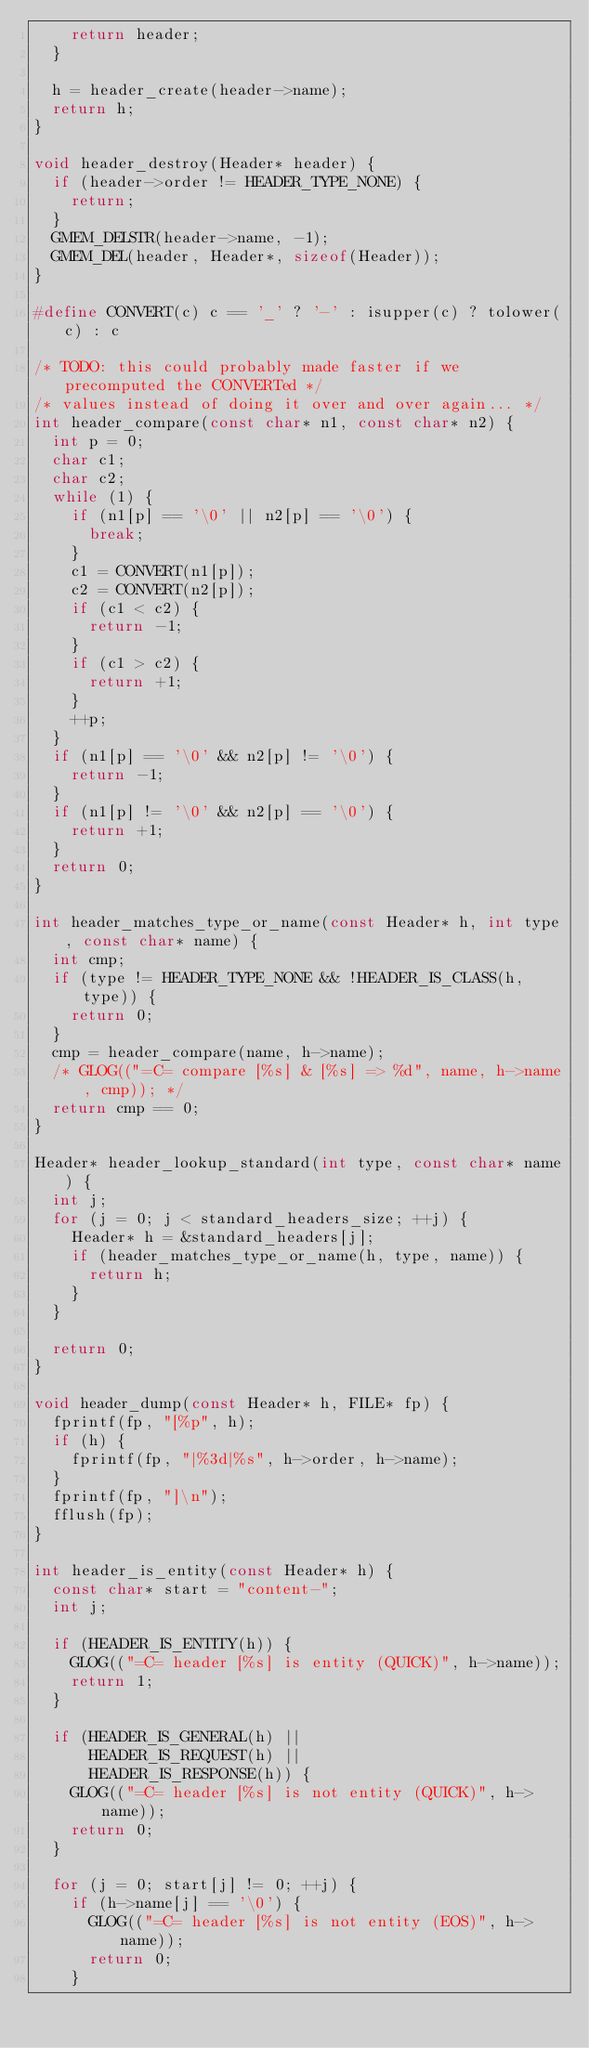<code> <loc_0><loc_0><loc_500><loc_500><_C_>    return header;
  }

  h = header_create(header->name);
  return h;
}

void header_destroy(Header* header) {
  if (header->order != HEADER_TYPE_NONE) {
    return;
  }
  GMEM_DELSTR(header->name, -1);
  GMEM_DEL(header, Header*, sizeof(Header));
}

#define CONVERT(c) c == '_' ? '-' : isupper(c) ? tolower(c) : c

/* TODO: this could probably made faster if we precomputed the CONVERTed */
/* values instead of doing it over and over again... */
int header_compare(const char* n1, const char* n2) {
  int p = 0;
  char c1;
  char c2;
  while (1) {
    if (n1[p] == '\0' || n2[p] == '\0') {
      break;
    }
    c1 = CONVERT(n1[p]);
    c2 = CONVERT(n2[p]);
    if (c1 < c2) {
      return -1;
    }
    if (c1 > c2) {
      return +1;
    }
    ++p;
  }
  if (n1[p] == '\0' && n2[p] != '\0') {
    return -1;
  }
  if (n1[p] != '\0' && n2[p] == '\0') {
    return +1;
  }
  return 0;
}

int header_matches_type_or_name(const Header* h, int type, const char* name) {
  int cmp;
  if (type != HEADER_TYPE_NONE && !HEADER_IS_CLASS(h, type)) {
    return 0;
  }
  cmp = header_compare(name, h->name);
  /* GLOG(("=C= compare [%s] & [%s] => %d", name, h->name, cmp)); */
  return cmp == 0;
}

Header* header_lookup_standard(int type, const char* name) {
  int j;
  for (j = 0; j < standard_headers_size; ++j) {
    Header* h = &standard_headers[j];
    if (header_matches_type_or_name(h, type, name)) {
      return h;
    }
  }

  return 0;
}

void header_dump(const Header* h, FILE* fp) {
  fprintf(fp, "[%p", h);
  if (h) {
    fprintf(fp, "|%3d|%s", h->order, h->name);
  }
  fprintf(fp, "]\n");
  fflush(fp);
}

int header_is_entity(const Header* h) {
  const char* start = "content-";
  int j;

  if (HEADER_IS_ENTITY(h)) {
    GLOG(("=C= header [%s] is entity (QUICK)", h->name));
    return 1;
  }

  if (HEADER_IS_GENERAL(h) ||
      HEADER_IS_REQUEST(h) ||
      HEADER_IS_RESPONSE(h)) {
    GLOG(("=C= header [%s] is not entity (QUICK)", h->name));
    return 0;
  }

  for (j = 0; start[j] != 0; ++j) {
    if (h->name[j] == '\0') {
      GLOG(("=C= header [%s] is not entity (EOS)", h->name));
      return 0;
    }</code> 